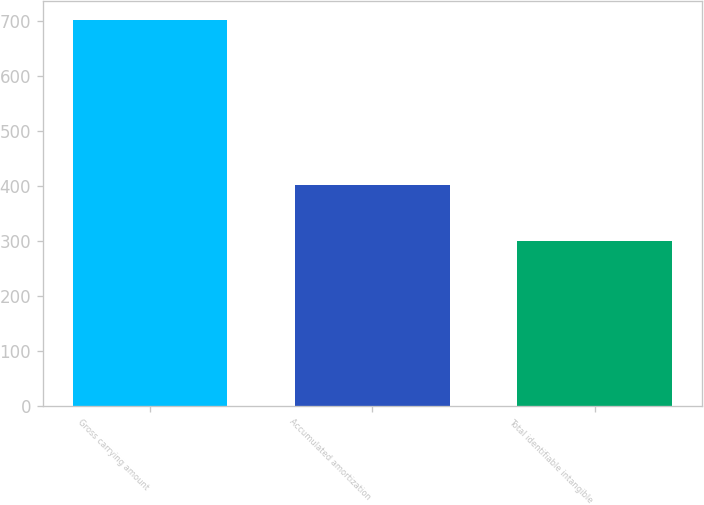<chart> <loc_0><loc_0><loc_500><loc_500><bar_chart><fcel>Gross carrying amount<fcel>Accumulated amortization<fcel>Total identifiable intangible<nl><fcel>700.4<fcel>401.4<fcel>299<nl></chart> 